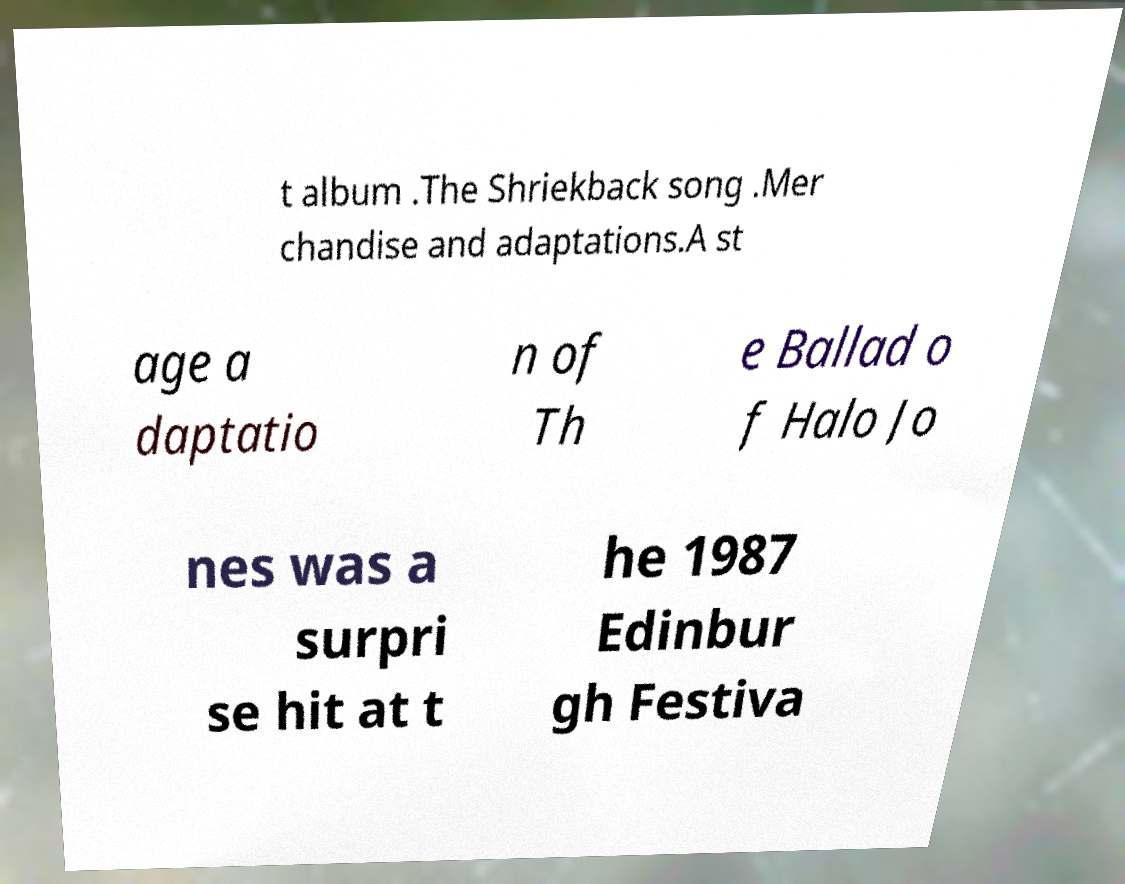There's text embedded in this image that I need extracted. Can you transcribe it verbatim? t album .The Shriekback song .Mer chandise and adaptations.A st age a daptatio n of Th e Ballad o f Halo Jo nes was a surpri se hit at t he 1987 Edinbur gh Festiva 